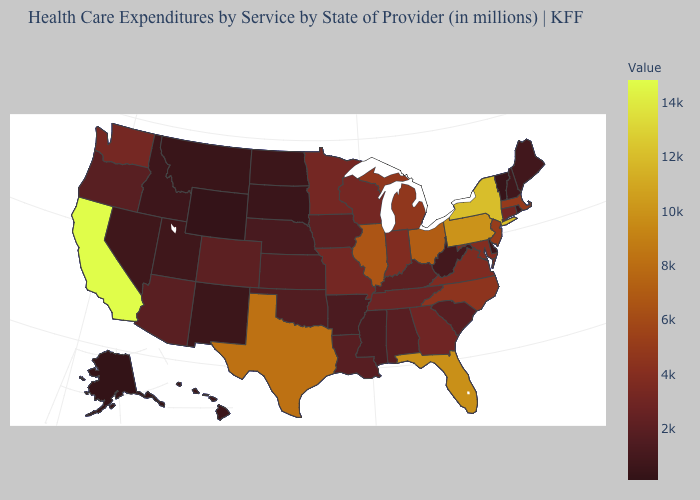Does the map have missing data?
Short answer required. No. Among the states that border Michigan , which have the lowest value?
Concise answer only. Wisconsin. Among the states that border Oklahoma , which have the highest value?
Concise answer only. Texas. 